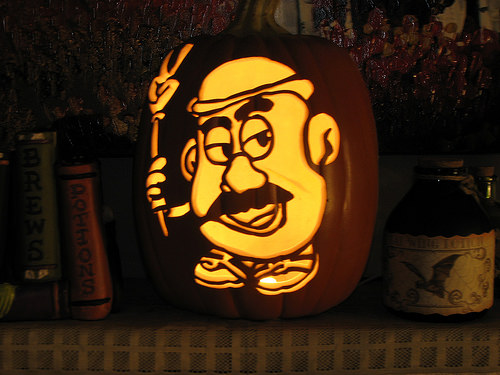<image>
Can you confirm if the bat is on the jar? Yes. Looking at the image, I can see the bat is positioned on top of the jar, with the jar providing support. Is the mr potato to the left of the jar? Yes. From this viewpoint, the mr potato is positioned to the left side relative to the jar. 